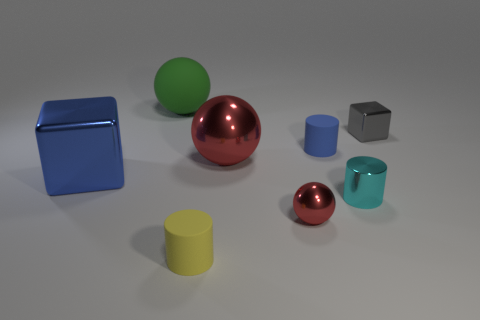Add 2 spheres. How many objects exist? 10 Subtract all balls. How many objects are left? 5 Add 7 tiny cyan objects. How many tiny cyan objects are left? 8 Add 2 tiny brown matte blocks. How many tiny brown matte blocks exist? 2 Subtract 0 red cylinders. How many objects are left? 8 Subtract all cyan metallic cylinders. Subtract all large blocks. How many objects are left? 6 